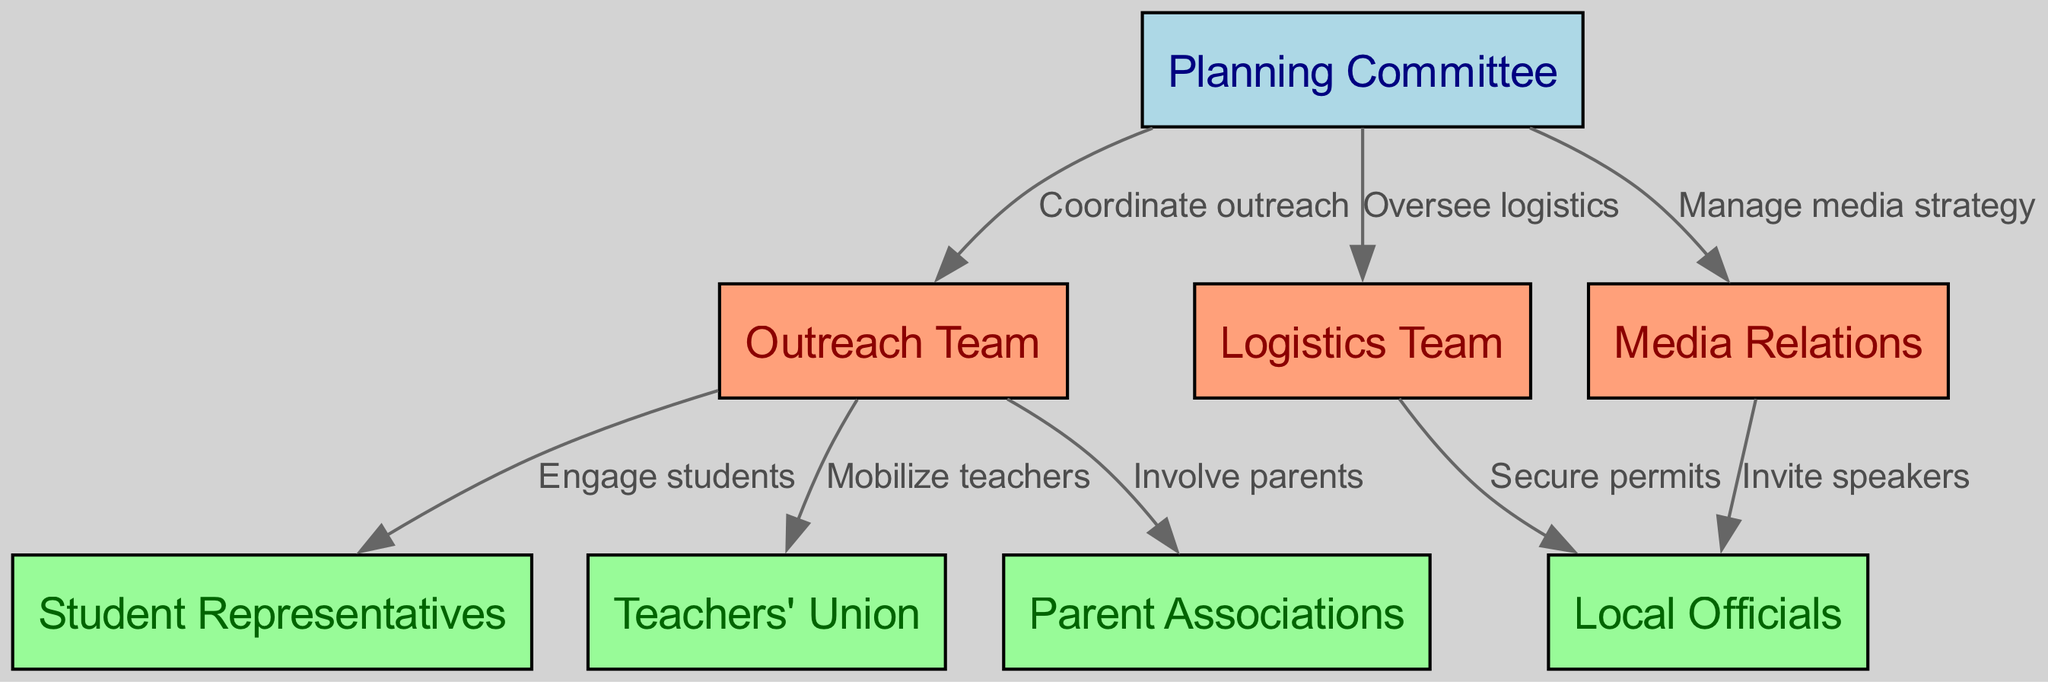What is the total number of nodes in the diagram? The diagram has eight distinct entities represented by nodes, which include both the planning and action teams as well as key stakeholder groups. I counted all the nodes to determine the total.
Answer: 8 Which team is responsible for overseeing logistics? The Logistics Team, which is identified as node 3, has a direct connection from the Planning Committee with the label "Oversee logistics." This indicates their role in the process.
Answer: Logistics Team Who does the Outreach Team engage with to mobilize support? The Outreach Team communicates with three groups, specifically engaging students, mobilizing teachers, and involving parents. This is shown through the edges connecting the Outreach Team to those stakeholder nodes.
Answer: Students, Teachers, Parents What action does the Planning Committee take regarding media? The Planning Committee manages the media strategy, which is indicated by the edge leading from the Planning Committee to the Media Relations node with the label "Manage media strategy."
Answer: Manage media strategy How many stakeholders are involved in the rally's organization? The diagram illustrates four key stakeholder groups: Student Representatives, Teachers' Union, Parent Associations, and Local Officials - providing a view of diverse community engagement. I counted those nodes to get the total specific to stakeholders.
Answer: 4 Which team is tasked with coordinating outreach? The Outreach Team is tasked with coordinating outreach according to the edge that connects from the Planning Committee labeled "Coordinate outreach." This clearly defines their responsibility in the organizing process.
Answer: Outreach Team What do the Logistics Team and Media Relations both coordinate with? Both the Logistics Team and Media Relations coordinate with Local Officials; the Logistics Team secures permits, and Media Relations invites speakers, both represented by their respective edges leading to the Local Officials' node.
Answer: Local Officials Which node directly connects to the Planning Committee for media strategy? Media Relations is the node that directly connects to the Planning Committee to manage the media strategy as specified by the edge labeled "Manage media strategy." This outlines who is involved in that aspect of planning.
Answer: Media Relations What is the relationship between the Outreach Team and the Teachers' Union? The relationship is one of mobilization, where the Outreach Team engages and collaborates with the Teachers' Union to gather support. This connection is shown by the edge that defines their interaction as "Mobilize teachers."
Answer: Mobilize teachers 